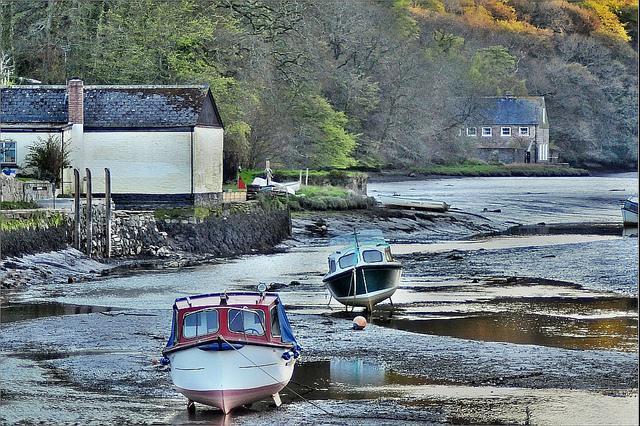How many boats are there?
Give a very brief answer. 2. 